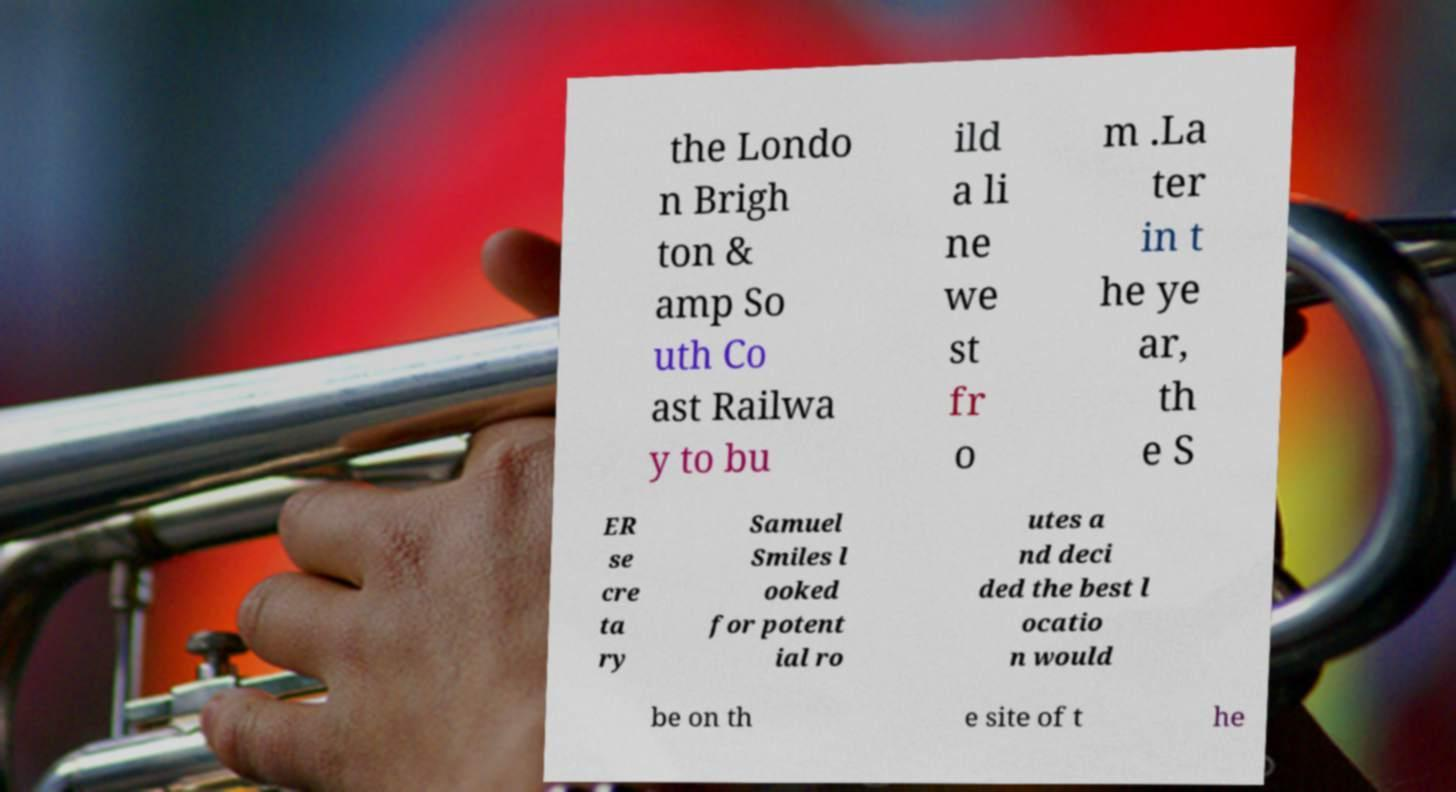There's text embedded in this image that I need extracted. Can you transcribe it verbatim? the Londo n Brigh ton & amp So uth Co ast Railwa y to bu ild a li ne we st fr o m .La ter in t he ye ar, th e S ER se cre ta ry Samuel Smiles l ooked for potent ial ro utes a nd deci ded the best l ocatio n would be on th e site of t he 